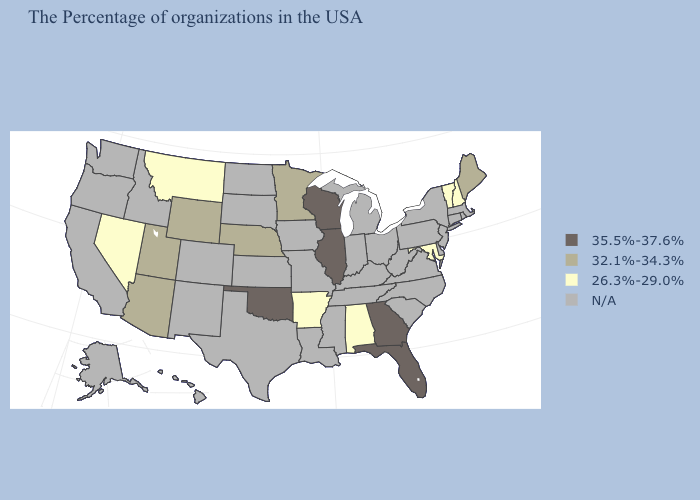What is the highest value in the USA?
Answer briefly. 35.5%-37.6%. Name the states that have a value in the range N/A?
Short answer required. Massachusetts, Rhode Island, Connecticut, New York, New Jersey, Delaware, Pennsylvania, Virginia, North Carolina, South Carolina, West Virginia, Ohio, Michigan, Kentucky, Indiana, Tennessee, Mississippi, Louisiana, Missouri, Iowa, Kansas, Texas, South Dakota, North Dakota, Colorado, New Mexico, Idaho, California, Washington, Oregon, Alaska, Hawaii. What is the value of Arkansas?
Quick response, please. 26.3%-29.0%. What is the highest value in the West ?
Concise answer only. 32.1%-34.3%. Among the states that border South Dakota , does Montana have the highest value?
Be succinct. No. Name the states that have a value in the range N/A?
Concise answer only. Massachusetts, Rhode Island, Connecticut, New York, New Jersey, Delaware, Pennsylvania, Virginia, North Carolina, South Carolina, West Virginia, Ohio, Michigan, Kentucky, Indiana, Tennessee, Mississippi, Louisiana, Missouri, Iowa, Kansas, Texas, South Dakota, North Dakota, Colorado, New Mexico, Idaho, California, Washington, Oregon, Alaska, Hawaii. Among the states that border Utah , which have the lowest value?
Keep it brief. Nevada. Name the states that have a value in the range 26.3%-29.0%?
Quick response, please. New Hampshire, Vermont, Maryland, Alabama, Arkansas, Montana, Nevada. Name the states that have a value in the range 35.5%-37.6%?
Be succinct. Florida, Georgia, Wisconsin, Illinois, Oklahoma. Name the states that have a value in the range 32.1%-34.3%?
Be succinct. Maine, Minnesota, Nebraska, Wyoming, Utah, Arizona. Which states hav the highest value in the Northeast?
Concise answer only. Maine. 